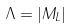Convert formula to latex. <formula><loc_0><loc_0><loc_500><loc_500>\Lambda = | M _ { L } |</formula> 